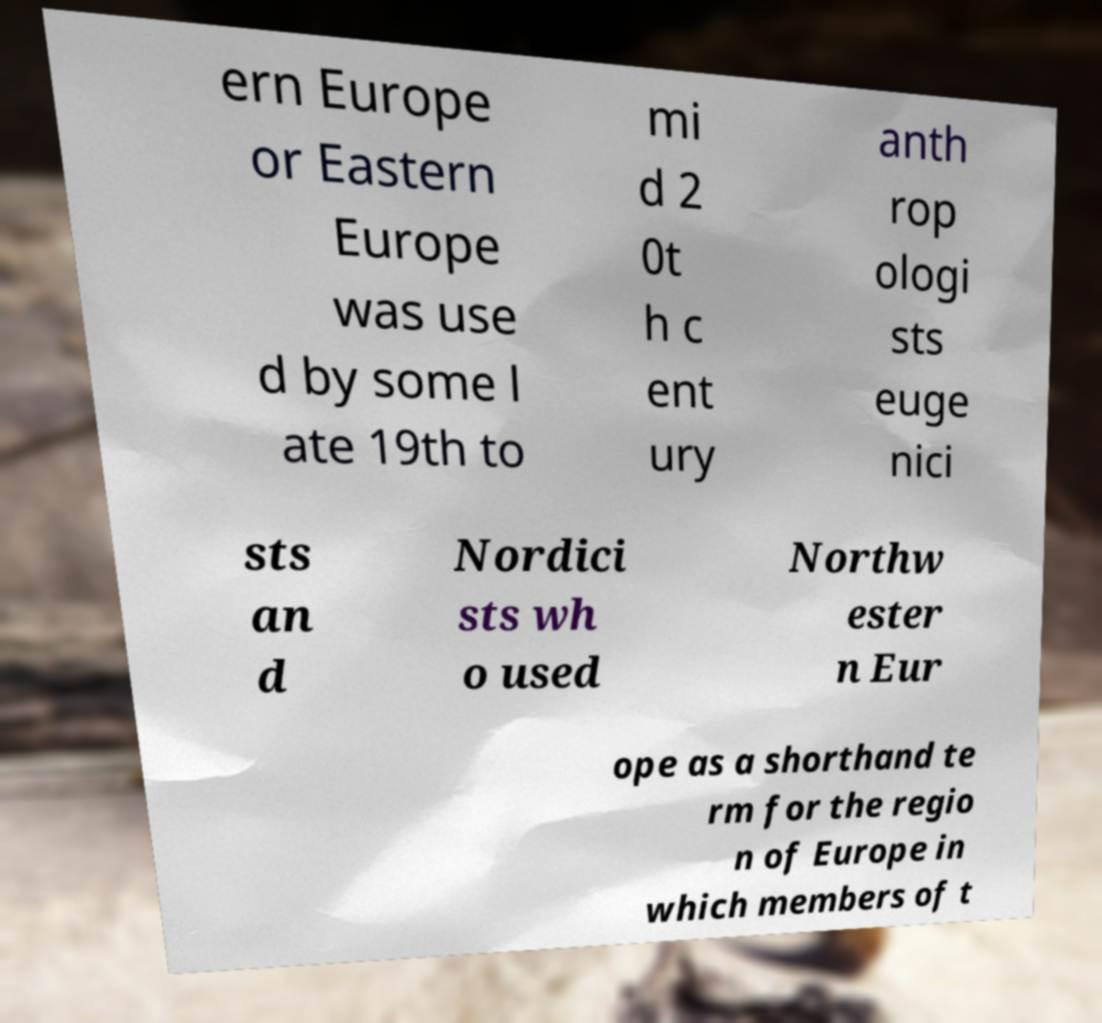What messages or text are displayed in this image? I need them in a readable, typed format. ern Europe or Eastern Europe was use d by some l ate 19th to mi d 2 0t h c ent ury anth rop ologi sts euge nici sts an d Nordici sts wh o used Northw ester n Eur ope as a shorthand te rm for the regio n of Europe in which members of t 